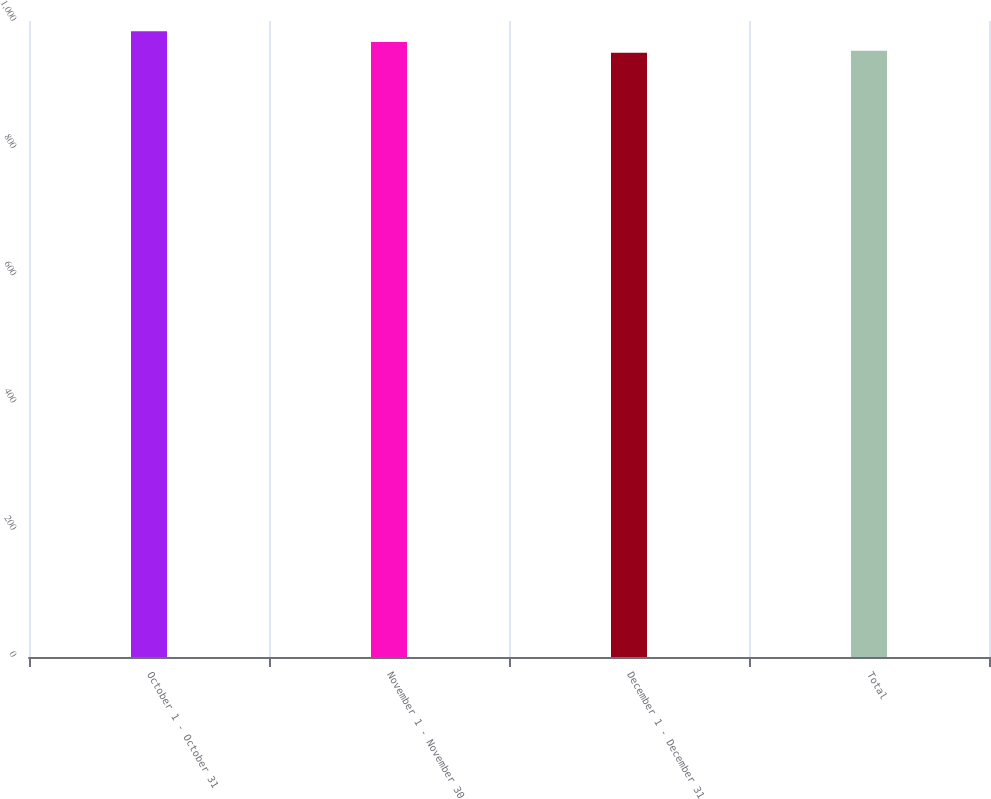Convert chart to OTSL. <chart><loc_0><loc_0><loc_500><loc_500><bar_chart><fcel>October 1 - October 31<fcel>November 1 - November 30<fcel>December 1 - December 31<fcel>Total<nl><fcel>984<fcel>967<fcel>950<fcel>953.4<nl></chart> 